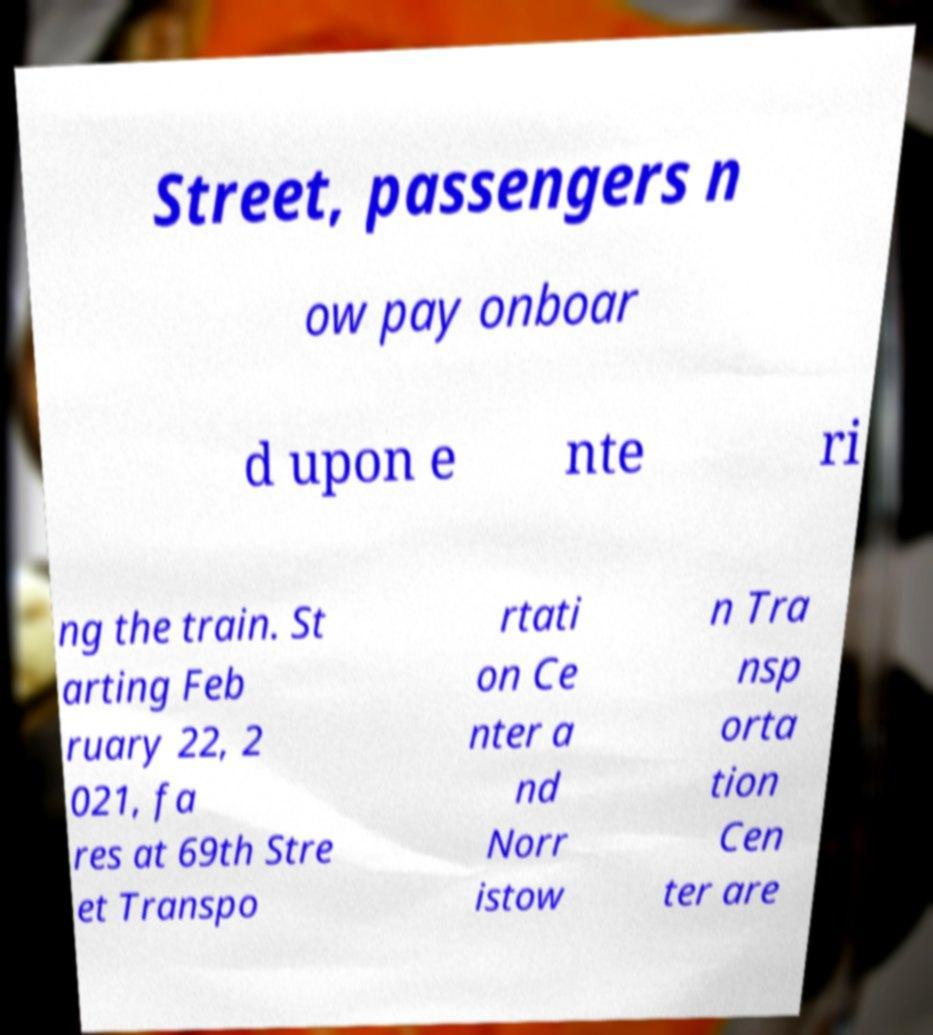For documentation purposes, I need the text within this image transcribed. Could you provide that? Street, passengers n ow pay onboar d upon e nte ri ng the train. St arting Feb ruary 22, 2 021, fa res at 69th Stre et Transpo rtati on Ce nter a nd Norr istow n Tra nsp orta tion Cen ter are 